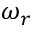Convert formula to latex. <formula><loc_0><loc_0><loc_500><loc_500>\omega _ { r }</formula> 